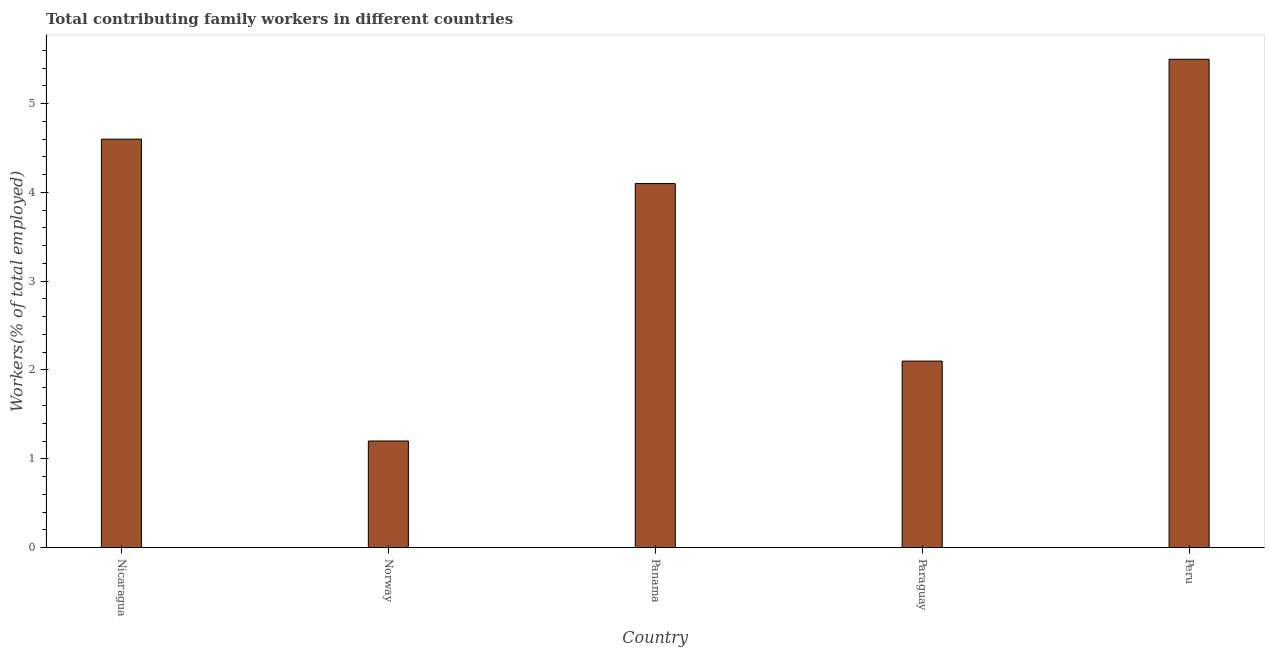Does the graph contain any zero values?
Offer a very short reply. No. What is the title of the graph?
Your response must be concise. Total contributing family workers in different countries. What is the label or title of the X-axis?
Give a very brief answer. Country. What is the label or title of the Y-axis?
Provide a short and direct response. Workers(% of total employed). What is the contributing family workers in Paraguay?
Your answer should be compact. 2.1. Across all countries, what is the maximum contributing family workers?
Keep it short and to the point. 5.5. Across all countries, what is the minimum contributing family workers?
Your response must be concise. 1.2. In which country was the contributing family workers maximum?
Your answer should be compact. Peru. What is the sum of the contributing family workers?
Offer a very short reply. 17.5. What is the difference between the contributing family workers in Paraguay and Peru?
Your answer should be compact. -3.4. What is the median contributing family workers?
Your response must be concise. 4.1. In how many countries, is the contributing family workers greater than 4.6 %?
Offer a very short reply. 1. What is the ratio of the contributing family workers in Nicaragua to that in Panama?
Your response must be concise. 1.12. Is the contributing family workers in Norway less than that in Peru?
Your answer should be very brief. Yes. Is the difference between the contributing family workers in Panama and Paraguay greater than the difference between any two countries?
Your response must be concise. No. What is the difference between the highest and the second highest contributing family workers?
Make the answer very short. 0.9. What is the difference between the highest and the lowest contributing family workers?
Keep it short and to the point. 4.3. In how many countries, is the contributing family workers greater than the average contributing family workers taken over all countries?
Keep it short and to the point. 3. How many bars are there?
Provide a succinct answer. 5. What is the difference between two consecutive major ticks on the Y-axis?
Offer a terse response. 1. What is the Workers(% of total employed) in Nicaragua?
Your response must be concise. 4.6. What is the Workers(% of total employed) of Norway?
Your response must be concise. 1.2. What is the Workers(% of total employed) of Panama?
Offer a terse response. 4.1. What is the Workers(% of total employed) of Paraguay?
Your answer should be compact. 2.1. What is the Workers(% of total employed) in Peru?
Your answer should be very brief. 5.5. What is the difference between the Workers(% of total employed) in Nicaragua and Norway?
Your answer should be very brief. 3.4. What is the difference between the Workers(% of total employed) in Nicaragua and Panama?
Make the answer very short. 0.5. What is the difference between the Workers(% of total employed) in Nicaragua and Paraguay?
Offer a terse response. 2.5. What is the difference between the Workers(% of total employed) in Norway and Peru?
Offer a very short reply. -4.3. What is the difference between the Workers(% of total employed) in Panama and Paraguay?
Give a very brief answer. 2. What is the difference between the Workers(% of total employed) in Paraguay and Peru?
Keep it short and to the point. -3.4. What is the ratio of the Workers(% of total employed) in Nicaragua to that in Norway?
Your answer should be compact. 3.83. What is the ratio of the Workers(% of total employed) in Nicaragua to that in Panama?
Keep it short and to the point. 1.12. What is the ratio of the Workers(% of total employed) in Nicaragua to that in Paraguay?
Offer a very short reply. 2.19. What is the ratio of the Workers(% of total employed) in Nicaragua to that in Peru?
Offer a very short reply. 0.84. What is the ratio of the Workers(% of total employed) in Norway to that in Panama?
Provide a succinct answer. 0.29. What is the ratio of the Workers(% of total employed) in Norway to that in Paraguay?
Your answer should be compact. 0.57. What is the ratio of the Workers(% of total employed) in Norway to that in Peru?
Ensure brevity in your answer.  0.22. What is the ratio of the Workers(% of total employed) in Panama to that in Paraguay?
Your answer should be compact. 1.95. What is the ratio of the Workers(% of total employed) in Panama to that in Peru?
Keep it short and to the point. 0.74. What is the ratio of the Workers(% of total employed) in Paraguay to that in Peru?
Provide a short and direct response. 0.38. 